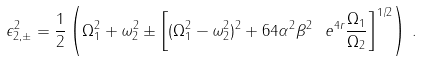<formula> <loc_0><loc_0><loc_500><loc_500>\epsilon _ { 2 , \pm } ^ { 2 } = \frac { 1 } { 2 } \left ( \Omega _ { 1 } ^ { 2 } + \omega _ { 2 } ^ { 2 } \pm \left [ ( \Omega _ { 1 } ^ { 2 } - \omega _ { 2 } ^ { 2 } ) ^ { 2 } + 6 4 \alpha ^ { 2 } \beta ^ { 2 } \ e ^ { 4 r } \frac { \Omega _ { 1 } } { \Omega _ { 2 } } \right ] ^ { 1 / 2 } \right ) \, .</formula> 